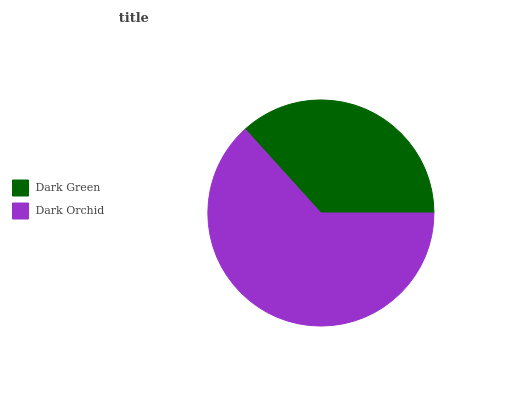Is Dark Green the minimum?
Answer yes or no. Yes. Is Dark Orchid the maximum?
Answer yes or no. Yes. Is Dark Orchid the minimum?
Answer yes or no. No. Is Dark Orchid greater than Dark Green?
Answer yes or no. Yes. Is Dark Green less than Dark Orchid?
Answer yes or no. Yes. Is Dark Green greater than Dark Orchid?
Answer yes or no. No. Is Dark Orchid less than Dark Green?
Answer yes or no. No. Is Dark Orchid the high median?
Answer yes or no. Yes. Is Dark Green the low median?
Answer yes or no. Yes. Is Dark Green the high median?
Answer yes or no. No. Is Dark Orchid the low median?
Answer yes or no. No. 